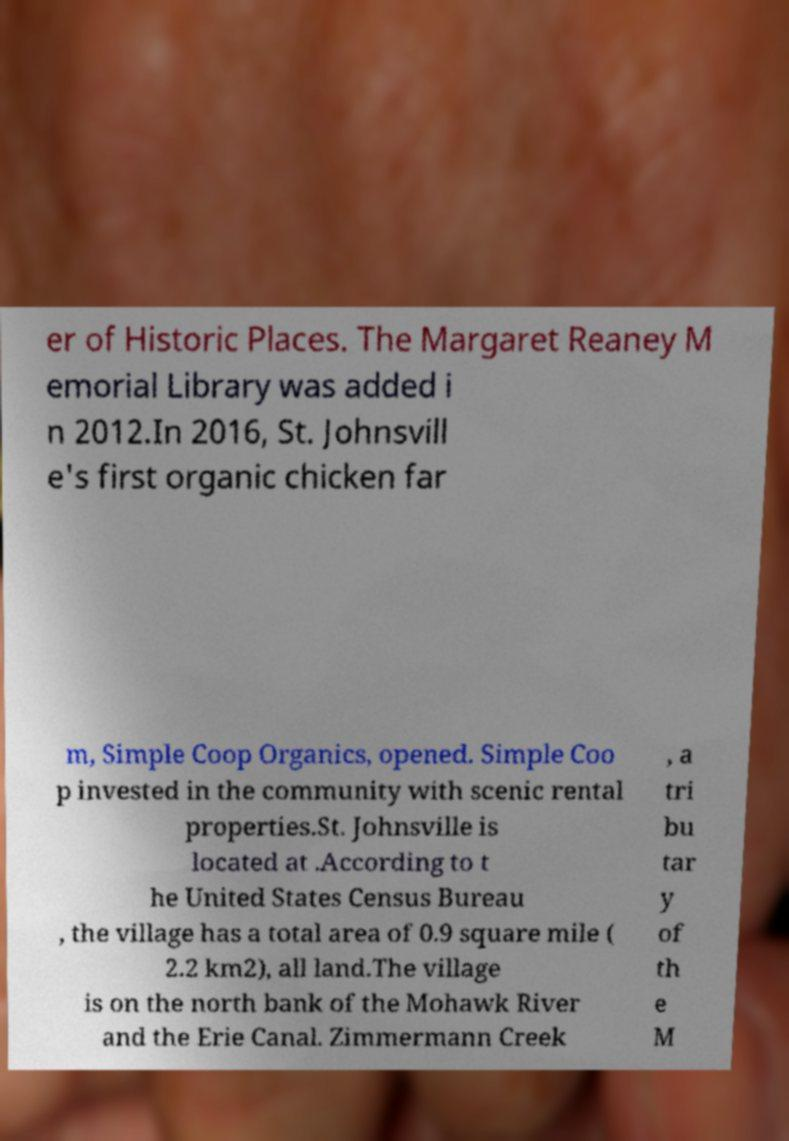Can you accurately transcribe the text from the provided image for me? er of Historic Places. The Margaret Reaney M emorial Library was added i n 2012.In 2016, St. Johnsvill e's first organic chicken far m, Simple Coop Organics, opened. Simple Coo p invested in the community with scenic rental properties.St. Johnsville is located at .According to t he United States Census Bureau , the village has a total area of 0.9 square mile ( 2.2 km2), all land.The village is on the north bank of the Mohawk River and the Erie Canal. Zimmermann Creek , a tri bu tar y of th e M 